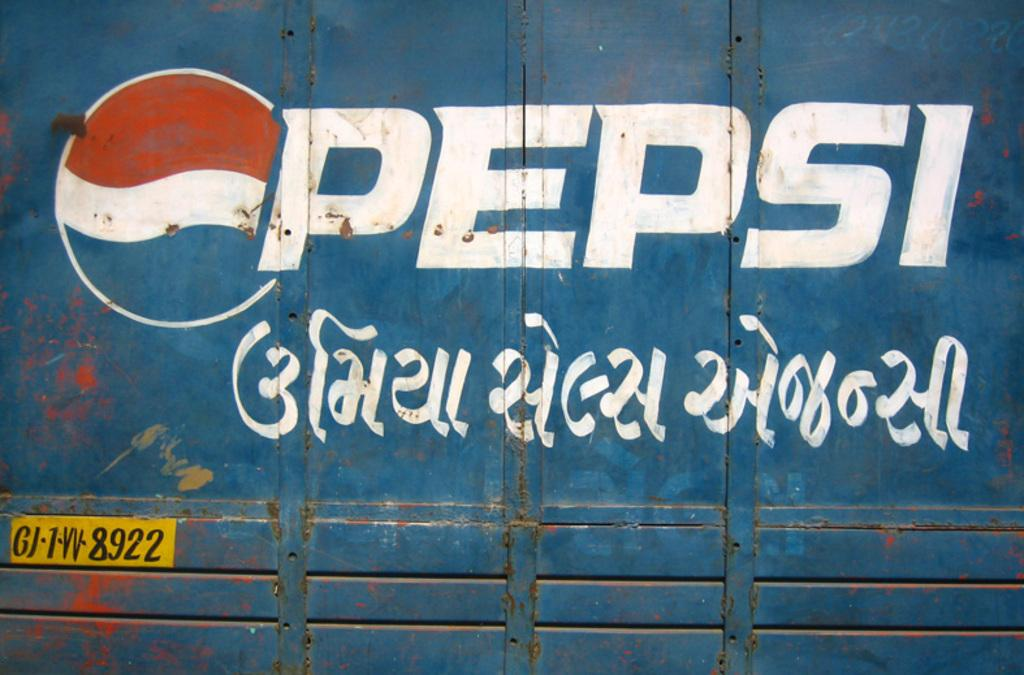<image>
Relay a brief, clear account of the picture shown. A sign of Pepsi with some other language in writing 